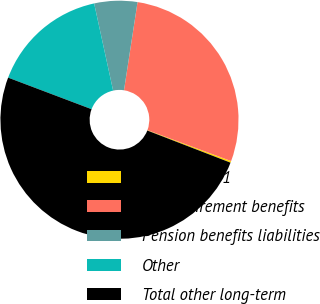Convert chart. <chart><loc_0><loc_0><loc_500><loc_500><pie_chart><fcel>December 31<fcel>Post-retirement benefits<fcel>Pension benefits liabilities<fcel>Other<fcel>Total other long-term<nl><fcel>0.23%<fcel>28.21%<fcel>5.84%<fcel>15.83%<fcel>49.88%<nl></chart> 